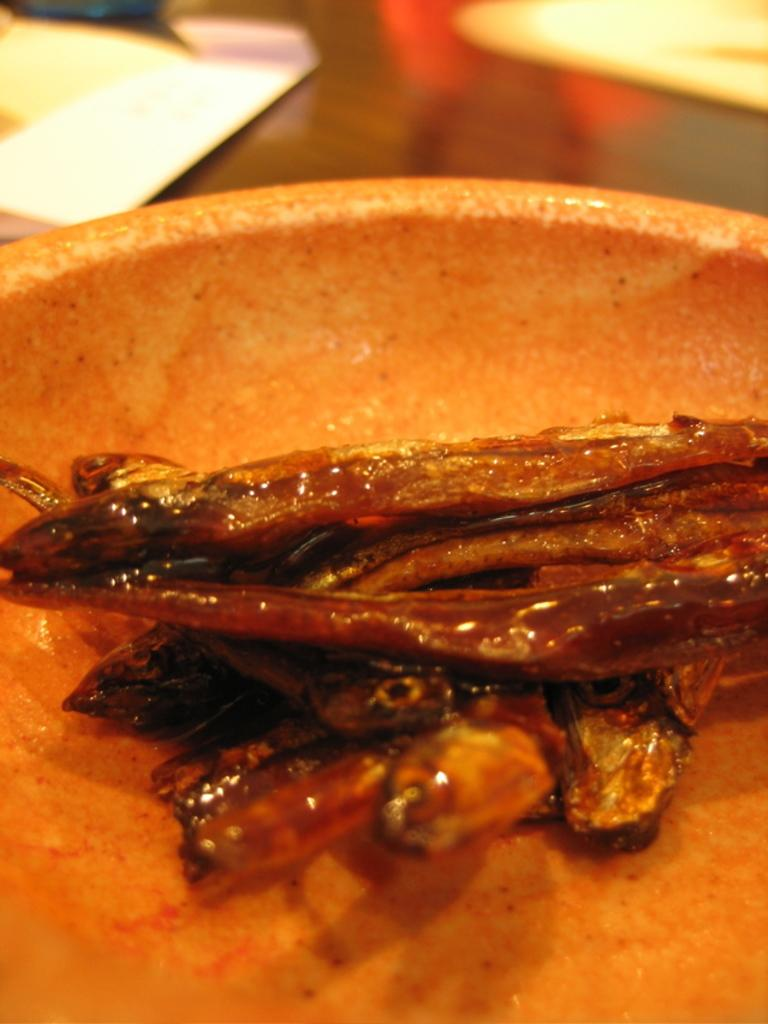What piece of furniture is present in the image? There is a table in the image. What is on top of the table? There is a plate containing food and papers placed on the table. What type of boot can be seen on the table in the image? There is no boot present on the table in the image. What emotion is being expressed by the objects on the table in the image? The objects on the table do not express emotions, as they are inanimate. 